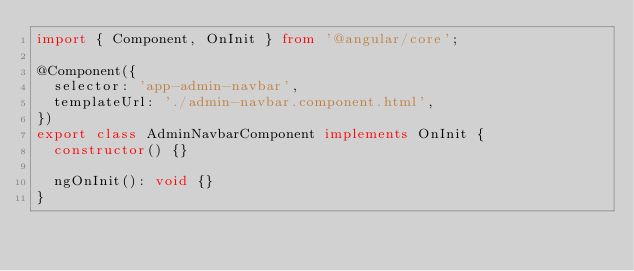<code> <loc_0><loc_0><loc_500><loc_500><_TypeScript_>import { Component, OnInit } from '@angular/core';

@Component({
  selector: 'app-admin-navbar',
  templateUrl: './admin-navbar.component.html',
})
export class AdminNavbarComponent implements OnInit {
  constructor() {}

  ngOnInit(): void {}
}
</code> 